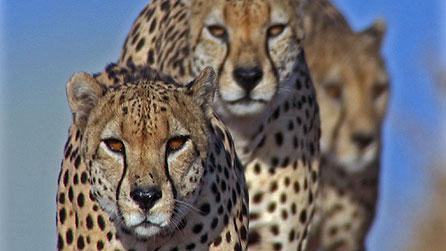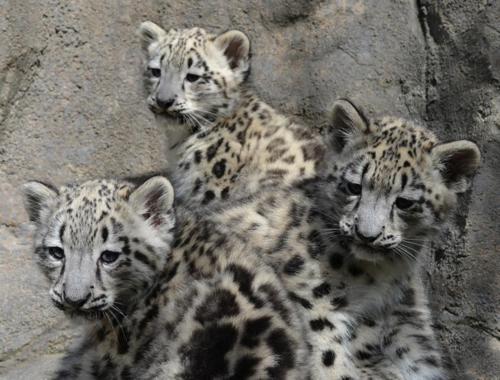The first image is the image on the left, the second image is the image on the right. Assess this claim about the two images: "the right image has three cheetas". Correct or not? Answer yes or no. Yes. The first image is the image on the left, the second image is the image on the right. For the images shown, is this caption "In the image on the right, there are no cheetahs - instead we have leopards, with broader faces, and larger spots, without the black tear duct path the cheetahs have." true? Answer yes or no. Yes. 